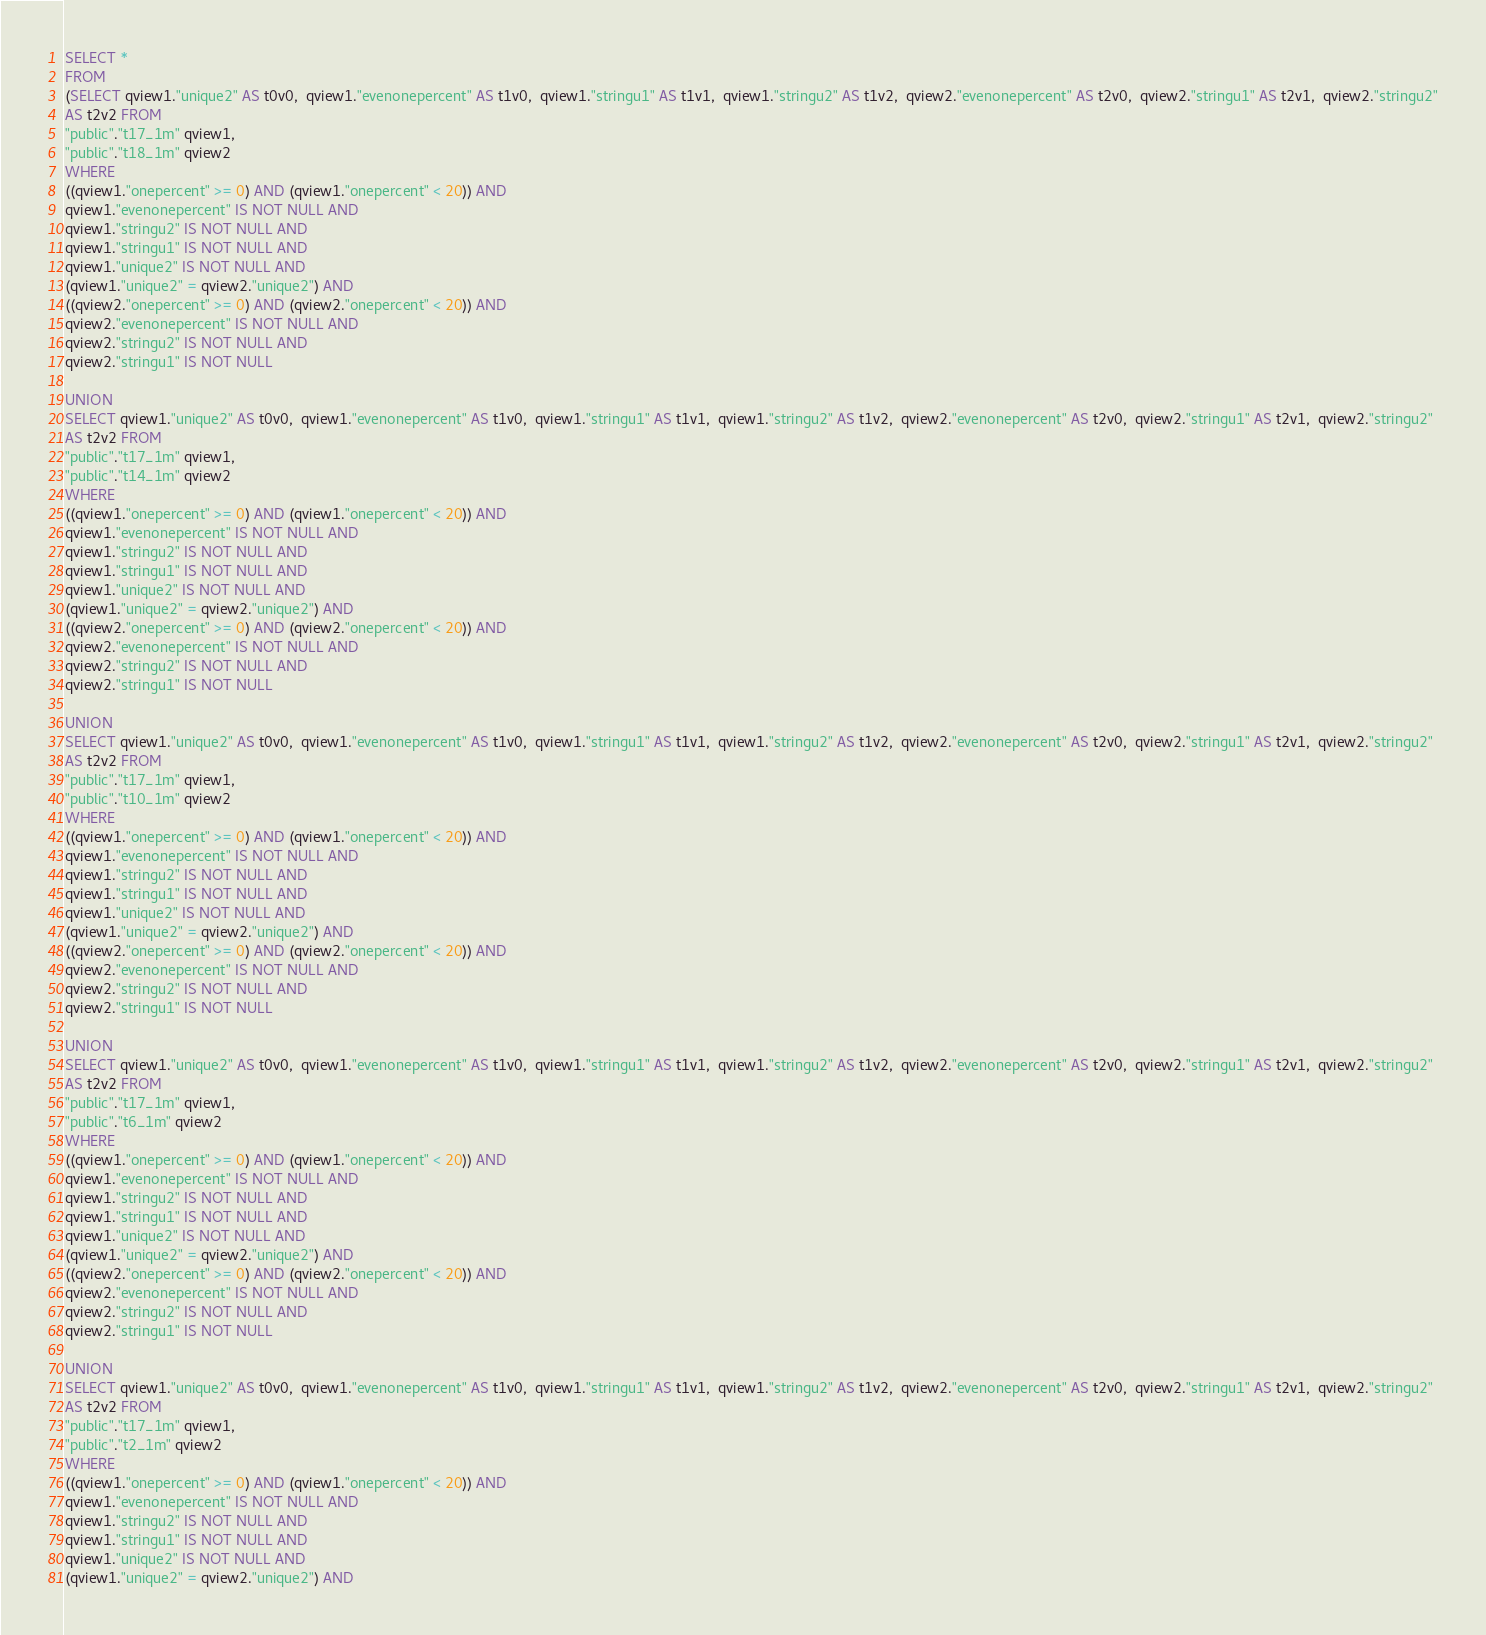<code> <loc_0><loc_0><loc_500><loc_500><_SQL_>SELECT *
FROM
(SELECT qview1."unique2" AS t0v0,  qview1."evenonepercent" AS t1v0,  qview1."stringu1" AS t1v1,  qview1."stringu2" AS t1v2,  qview2."evenonepercent" AS t2v0,  qview2."stringu1" AS t2v1,  qview2."stringu2"
AS t2v2 FROM
"public"."t17_1m" qview1,
"public"."t18_1m" qview2
WHERE
((qview1."onepercent" >= 0) AND (qview1."onepercent" < 20)) AND
qview1."evenonepercent" IS NOT NULL AND
qview1."stringu2" IS NOT NULL AND
qview1."stringu1" IS NOT NULL AND
qview1."unique2" IS NOT NULL AND
(qview1."unique2" = qview2."unique2") AND
((qview2."onepercent" >= 0) AND (qview2."onepercent" < 20)) AND
qview2."evenonepercent" IS NOT NULL AND
qview2."stringu2" IS NOT NULL AND
qview2."stringu1" IS NOT NULL

UNION
SELECT qview1."unique2" AS t0v0,  qview1."evenonepercent" AS t1v0,  qview1."stringu1" AS t1v1,  qview1."stringu2" AS t1v2,  qview2."evenonepercent" AS t2v0,  qview2."stringu1" AS t2v1,  qview2."stringu2"
AS t2v2 FROM
"public"."t17_1m" qview1,
"public"."t14_1m" qview2
WHERE
((qview1."onepercent" >= 0) AND (qview1."onepercent" < 20)) AND
qview1."evenonepercent" IS NOT NULL AND
qview1."stringu2" IS NOT NULL AND
qview1."stringu1" IS NOT NULL AND
qview1."unique2" IS NOT NULL AND
(qview1."unique2" = qview2."unique2") AND
((qview2."onepercent" >= 0) AND (qview2."onepercent" < 20)) AND
qview2."evenonepercent" IS NOT NULL AND
qview2."stringu2" IS NOT NULL AND
qview2."stringu1" IS NOT NULL

UNION
SELECT qview1."unique2" AS t0v0,  qview1."evenonepercent" AS t1v0,  qview1."stringu1" AS t1v1,  qview1."stringu2" AS t1v2,  qview2."evenonepercent" AS t2v0,  qview2."stringu1" AS t2v1,  qview2."stringu2"
AS t2v2 FROM
"public"."t17_1m" qview1,
"public"."t10_1m" qview2
WHERE
((qview1."onepercent" >= 0) AND (qview1."onepercent" < 20)) AND
qview1."evenonepercent" IS NOT NULL AND
qview1."stringu2" IS NOT NULL AND
qview1."stringu1" IS NOT NULL AND
qview1."unique2" IS NOT NULL AND
(qview1."unique2" = qview2."unique2") AND
((qview2."onepercent" >= 0) AND (qview2."onepercent" < 20)) AND
qview2."evenonepercent" IS NOT NULL AND
qview2."stringu2" IS NOT NULL AND
qview2."stringu1" IS NOT NULL

UNION
SELECT qview1."unique2" AS t0v0,  qview1."evenonepercent" AS t1v0,  qview1."stringu1" AS t1v1,  qview1."stringu2" AS t1v2,  qview2."evenonepercent" AS t2v0,  qview2."stringu1" AS t2v1,  qview2."stringu2"
AS t2v2 FROM
"public"."t17_1m" qview1,
"public"."t6_1m" qview2
WHERE
((qview1."onepercent" >= 0) AND (qview1."onepercent" < 20)) AND
qview1."evenonepercent" IS NOT NULL AND
qview1."stringu2" IS NOT NULL AND
qview1."stringu1" IS NOT NULL AND
qview1."unique2" IS NOT NULL AND
(qview1."unique2" = qview2."unique2") AND
((qview2."onepercent" >= 0) AND (qview2."onepercent" < 20)) AND
qview2."evenonepercent" IS NOT NULL AND
qview2."stringu2" IS NOT NULL AND
qview2."stringu1" IS NOT NULL

UNION
SELECT qview1."unique2" AS t0v0,  qview1."evenonepercent" AS t1v0,  qview1."stringu1" AS t1v1,  qview1."stringu2" AS t1v2,  qview2."evenonepercent" AS t2v0,  qview2."stringu1" AS t2v1,  qview2."stringu2"
AS t2v2 FROM
"public"."t17_1m" qview1,
"public"."t2_1m" qview2
WHERE
((qview1."onepercent" >= 0) AND (qview1."onepercent" < 20)) AND
qview1."evenonepercent" IS NOT NULL AND
qview1."stringu2" IS NOT NULL AND
qview1."stringu1" IS NOT NULL AND
qview1."unique2" IS NOT NULL AND
(qview1."unique2" = qview2."unique2") AND</code> 